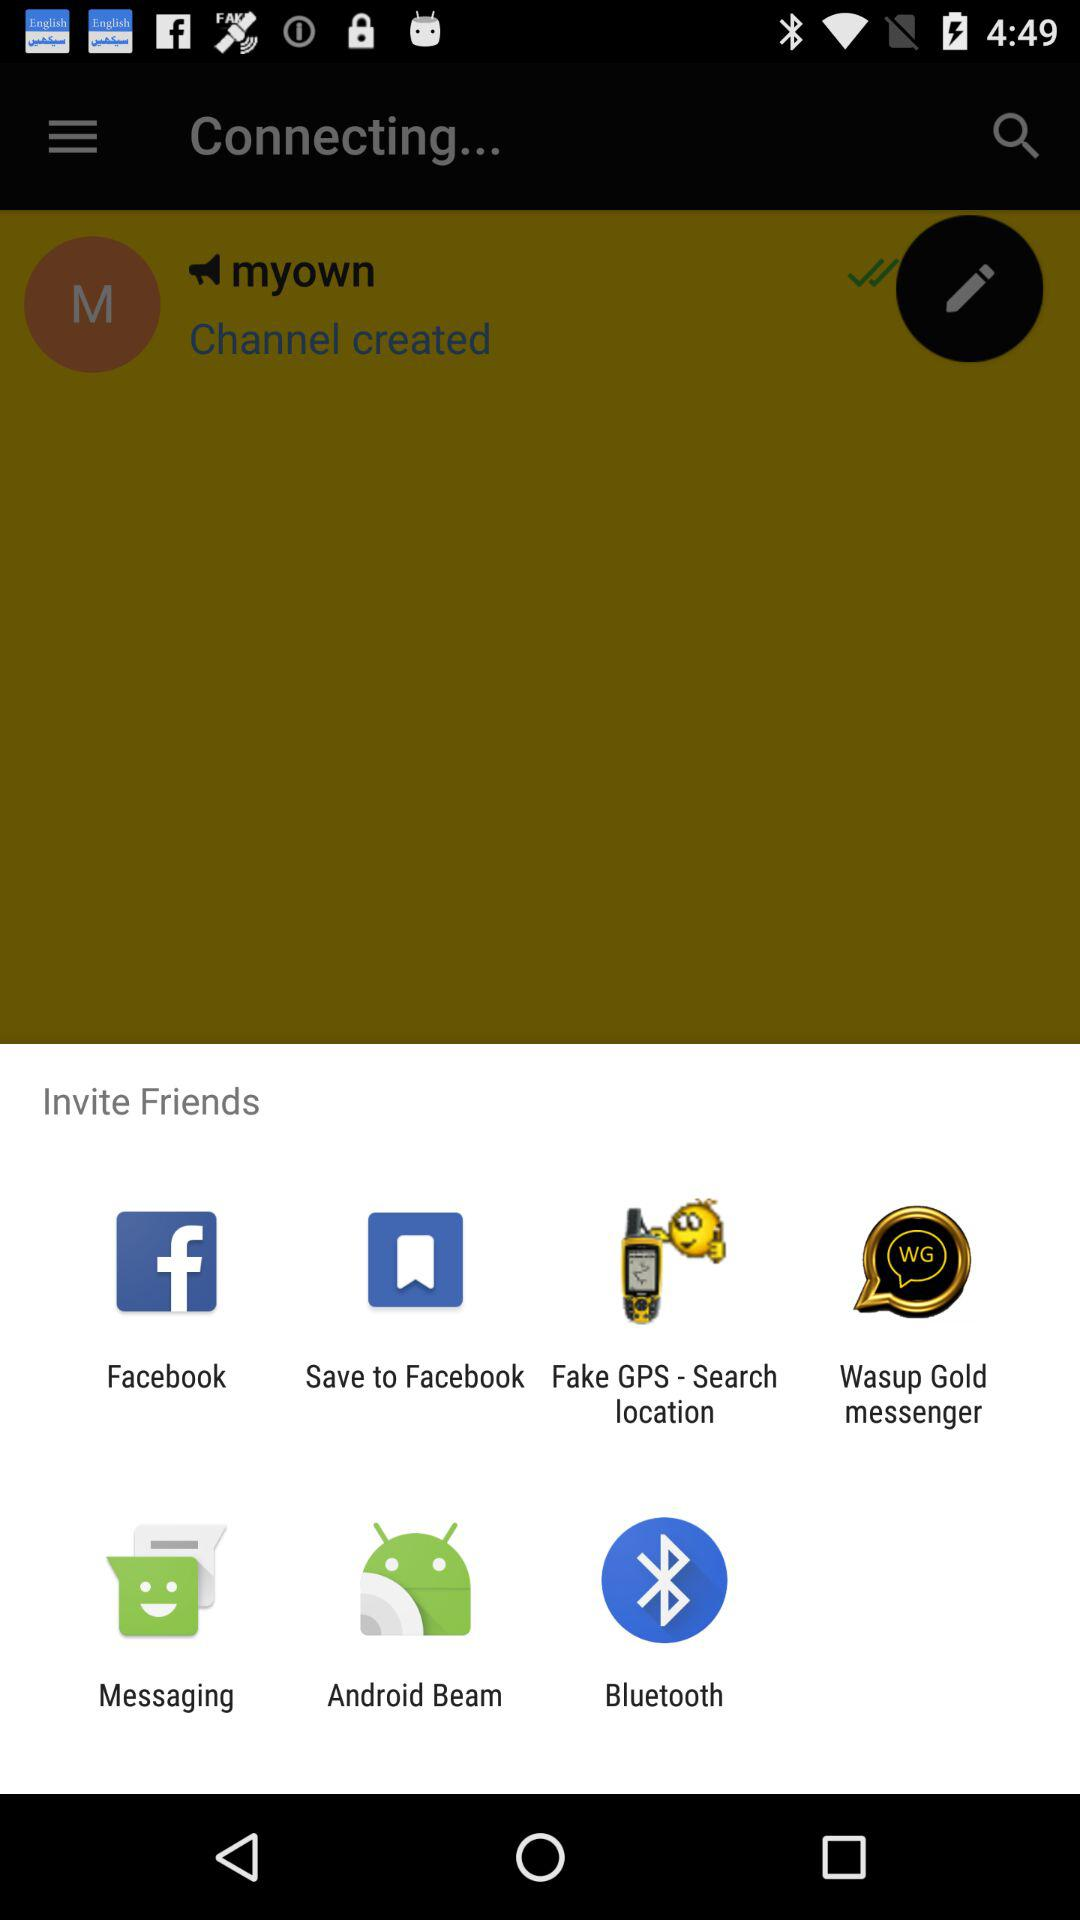What is the name of the application?
When the provided information is insufficient, respond with <no answer>. <no answer> 